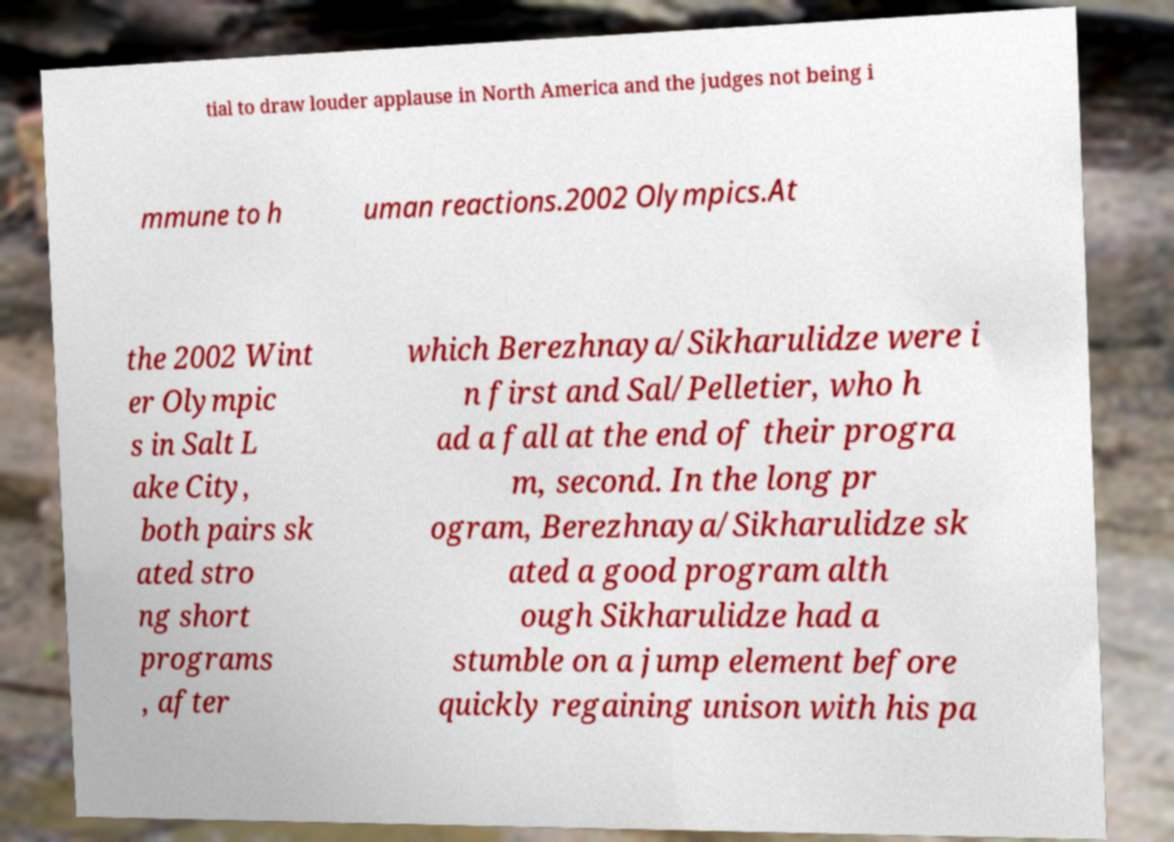Please read and relay the text visible in this image. What does it say? tial to draw louder applause in North America and the judges not being i mmune to h uman reactions.2002 Olympics.At the 2002 Wint er Olympic s in Salt L ake City, both pairs sk ated stro ng short programs , after which Berezhnaya/Sikharulidze were i n first and Sal/Pelletier, who h ad a fall at the end of their progra m, second. In the long pr ogram, Berezhnaya/Sikharulidze sk ated a good program alth ough Sikharulidze had a stumble on a jump element before quickly regaining unison with his pa 